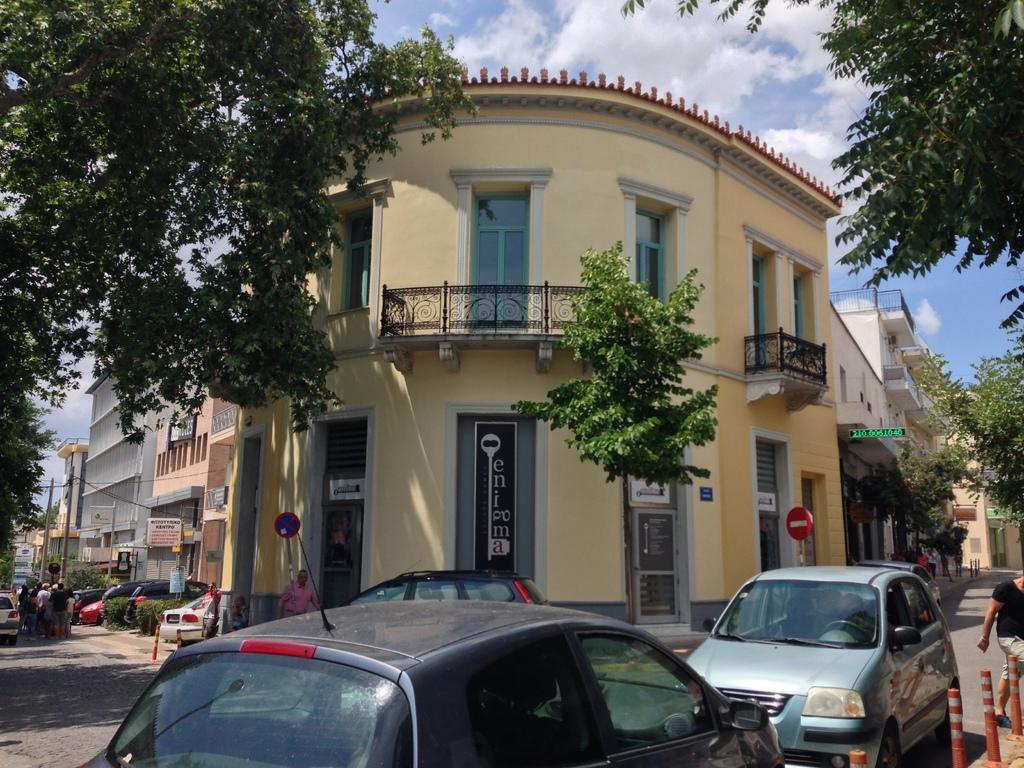Please provide a concise description of this image. In this image we can see the buildings, in front of the buildings there are vehicles and persons on the road. And we can see the poles, trees and sky in the background. 